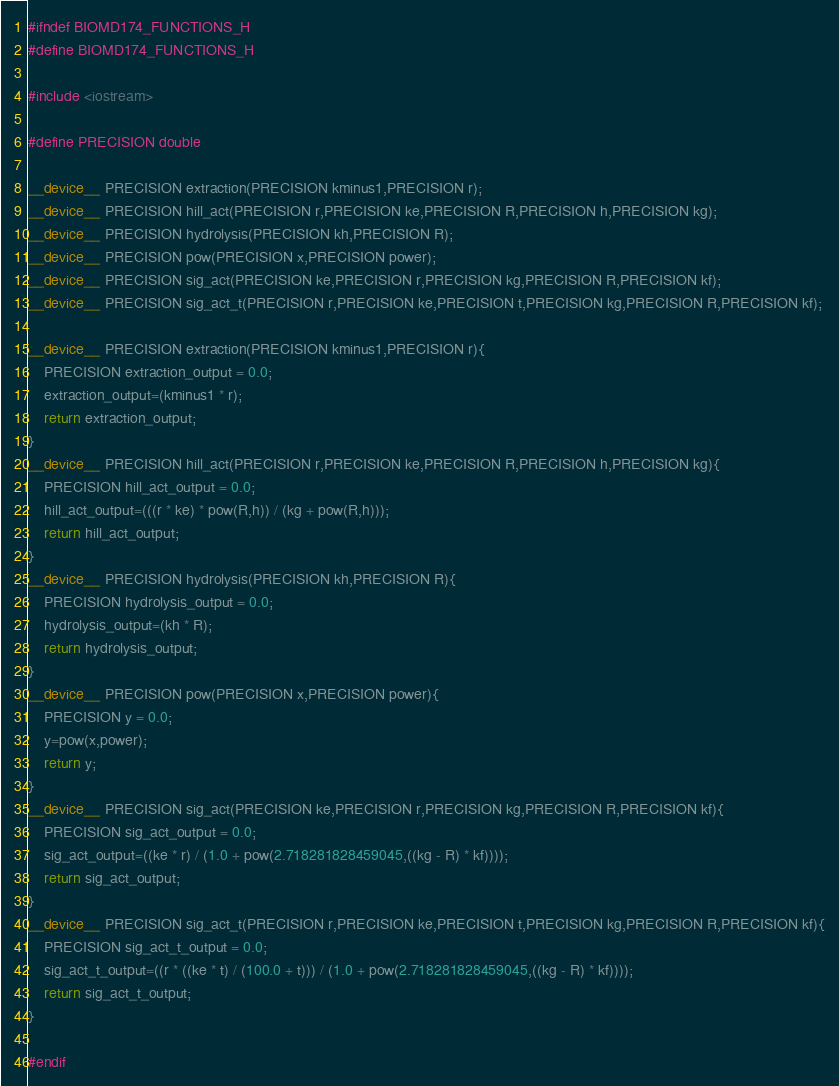Convert code to text. <code><loc_0><loc_0><loc_500><loc_500><_Cuda_>
#ifndef BIOMD174_FUNCTIONS_H
#define BIOMD174_FUNCTIONS_H

#include <iostream>

#define PRECISION double

__device__ PRECISION extraction(PRECISION kminus1,PRECISION r);
__device__ PRECISION hill_act(PRECISION r,PRECISION ke,PRECISION R,PRECISION h,PRECISION kg);
__device__ PRECISION hydrolysis(PRECISION kh,PRECISION R);
__device__ PRECISION pow(PRECISION x,PRECISION power);
__device__ PRECISION sig_act(PRECISION ke,PRECISION r,PRECISION kg,PRECISION R,PRECISION kf);
__device__ PRECISION sig_act_t(PRECISION r,PRECISION ke,PRECISION t,PRECISION kg,PRECISION R,PRECISION kf);

__device__ PRECISION extraction(PRECISION kminus1,PRECISION r){
    PRECISION extraction_output = 0.0;
    extraction_output=(kminus1 * r);
    return extraction_output;
}
__device__ PRECISION hill_act(PRECISION r,PRECISION ke,PRECISION R,PRECISION h,PRECISION kg){
    PRECISION hill_act_output = 0.0;
    hill_act_output=(((r * ke) * pow(R,h)) / (kg + pow(R,h)));
    return hill_act_output;
}
__device__ PRECISION hydrolysis(PRECISION kh,PRECISION R){
    PRECISION hydrolysis_output = 0.0;
    hydrolysis_output=(kh * R);
    return hydrolysis_output;
}
__device__ PRECISION pow(PRECISION x,PRECISION power){
    PRECISION y = 0.0;
    y=pow(x,power);
    return y;
}
__device__ PRECISION sig_act(PRECISION ke,PRECISION r,PRECISION kg,PRECISION R,PRECISION kf){
    PRECISION sig_act_output = 0.0;
    sig_act_output=((ke * r) / (1.0 + pow(2.718281828459045,((kg - R) * kf))));
    return sig_act_output;
}
__device__ PRECISION sig_act_t(PRECISION r,PRECISION ke,PRECISION t,PRECISION kg,PRECISION R,PRECISION kf){
    PRECISION sig_act_t_output = 0.0;
    sig_act_t_output=((r * ((ke * t) / (100.0 + t))) / (1.0 + pow(2.718281828459045,((kg - R) * kf))));
    return sig_act_t_output;
}

#endif
</code> 